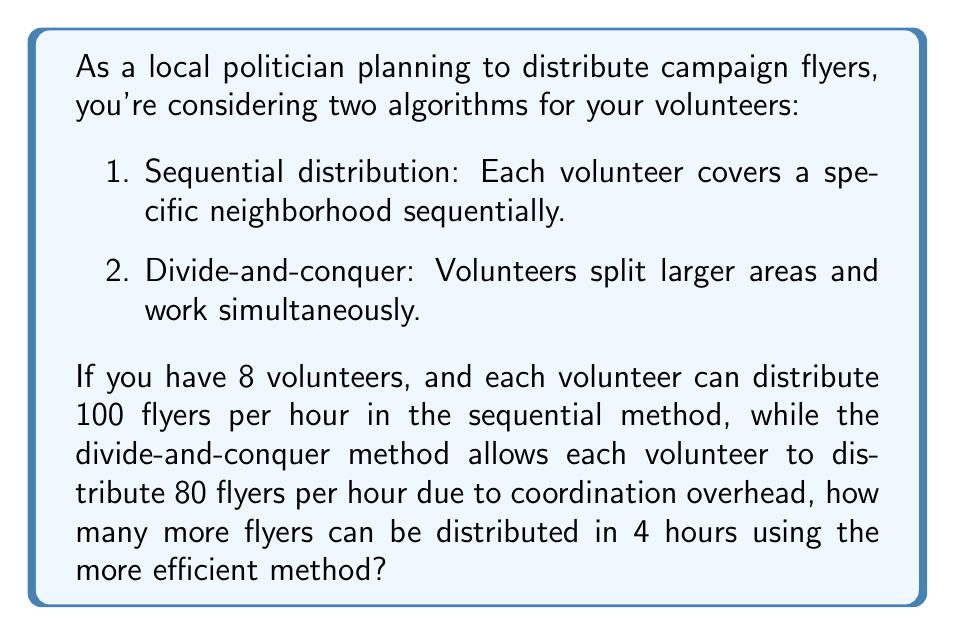Help me with this question. Let's analyze both methods:

1. Sequential distribution:
   - Each volunteer distributes 100 flyers/hour
   - Total flyers distributed per hour = $8 \times 100 = 800$
   - In 4 hours: $800 \times 4 = 3200$ flyers

2. Divide-and-conquer:
   - Each volunteer distributes 80 flyers/hour
   - Total flyers distributed per hour = $8 \times 80 = 640$
   - In 4 hours: $640 \times 4 = 2560$ flyers

To find the difference:

$$\text{Difference} = 3200 - 2560 = 640 \text{ flyers}$$

The sequential distribution method is more efficient in this case, allowing 640 more flyers to be distributed in 4 hours.

This problem demonstrates the importance of considering algorithmic efficiency in practical scenarios. While divide-and-conquer strategies often improve efficiency in computational problems, in this real-world scenario, the coordination overhead outweighs the potential benefits, making the simpler sequential approach more effective.
Answer: 640 flyers 